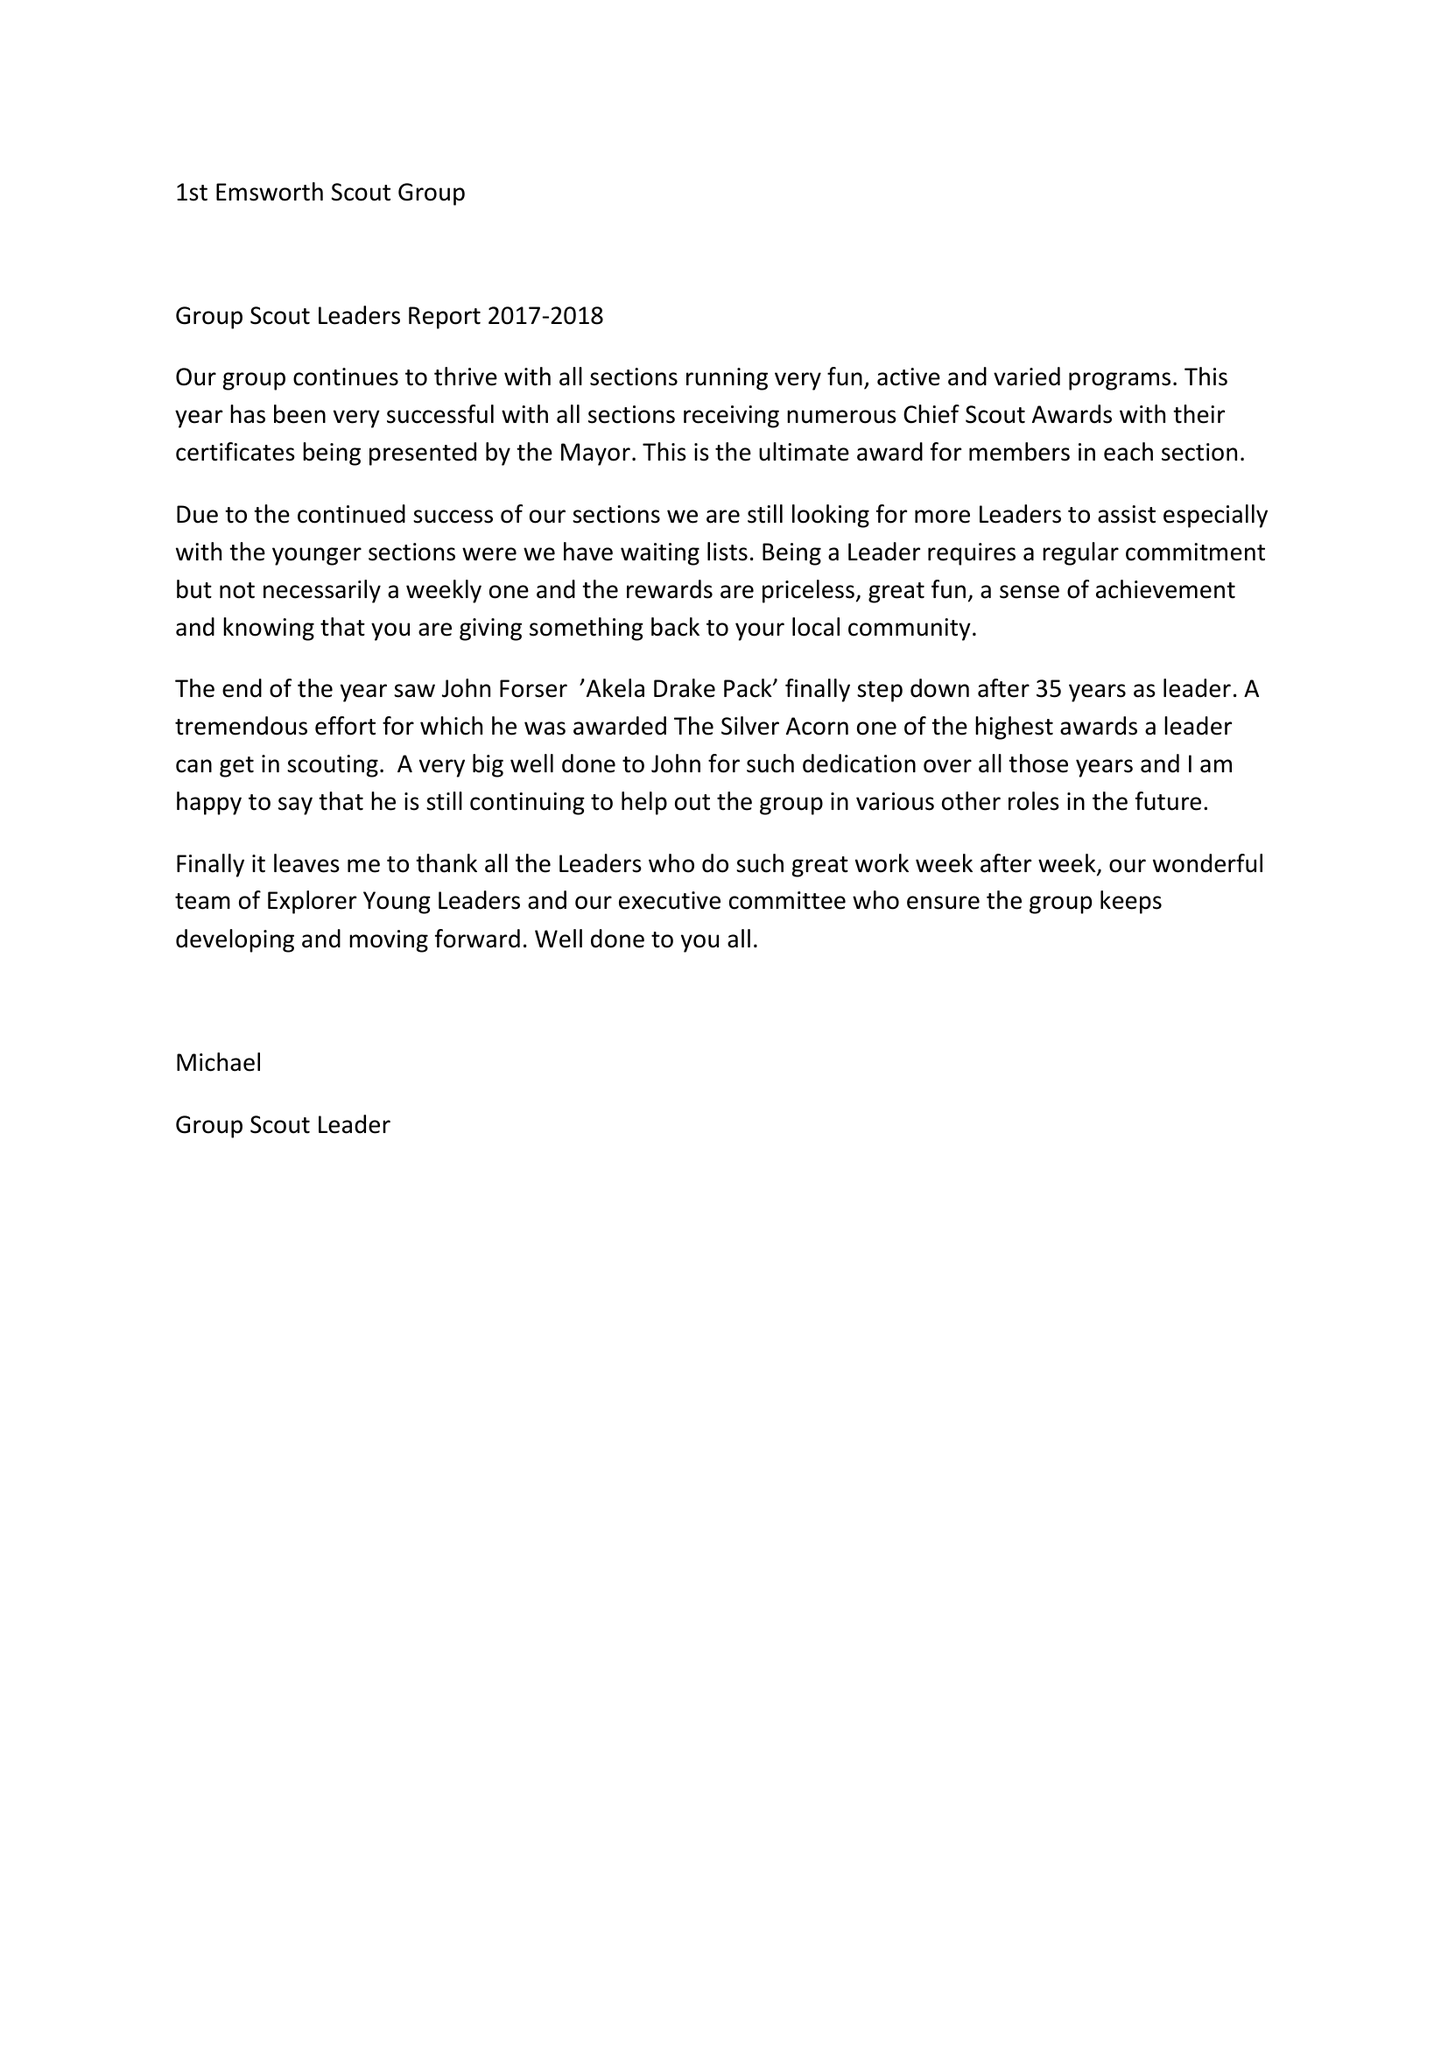What is the value for the income_annually_in_british_pounds?
Answer the question using a single word or phrase. 26941.00 